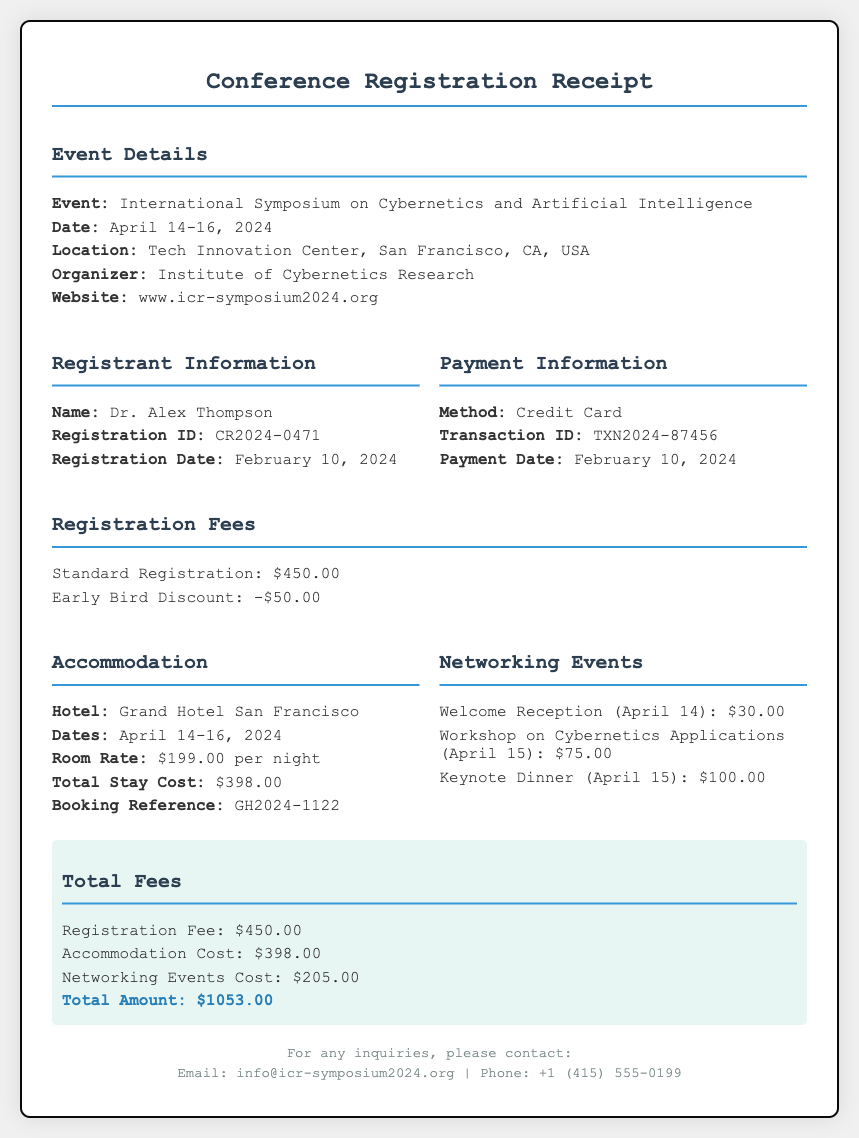What is the name of the conference? The name of the conference is provided in the event details section of the document.
Answer: International Symposium on Cybernetics and Artificial Intelligence What is the total amount to be paid? The total amount is calculated by adding up registration fees, accommodation costs, and networking events costs as seen in the total fees section.
Answer: $1053.00 What is the registration fee after the early bird discount? The registration fee can be determined by taking the standard fee and subtracting the early bird discount as indicated in the registration fees section.
Answer: $450.00 What are the dates of the event? The dates are mentioned in the event details, indicating when the conference takes place.
Answer: April 14-16, 2024 How much is the room rate per night? The room rate per night is listed in the accommodation section of the document.
Answer: $199.00 What is the booking reference for the hotel? The booking reference can be found in the accommodation section and provides a unique identifier for the hotel reservation.
Answer: GH2024-1122 How much does the Welcome Reception cost? The cost for the Welcome Reception can be found in the networking events section, indicating the fee for that particular event.
Answer: $30.00 Who is the organizer of the event? The organizer's name is listed in the event details section, providing information about who is managing the conference.
Answer: Institute of Cybernetics Research What method of payment was used? The payment method is specified in the payment information section of the receipt.
Answer: Credit Card 